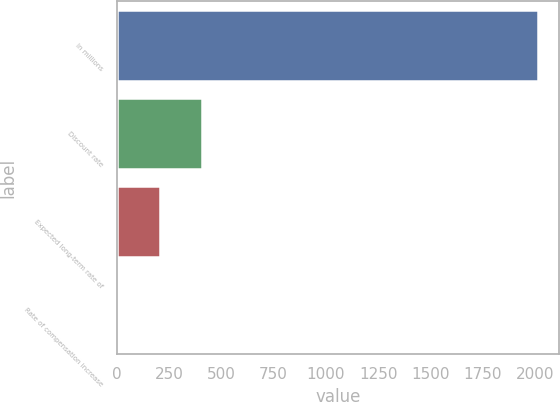Convert chart to OTSL. <chart><loc_0><loc_0><loc_500><loc_500><bar_chart><fcel>In millions<fcel>Discount rate<fcel>Expected long-term rate of<fcel>Rate of compensation increase<nl><fcel>2013<fcel>407.4<fcel>206.7<fcel>6<nl></chart> 